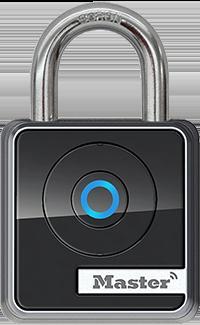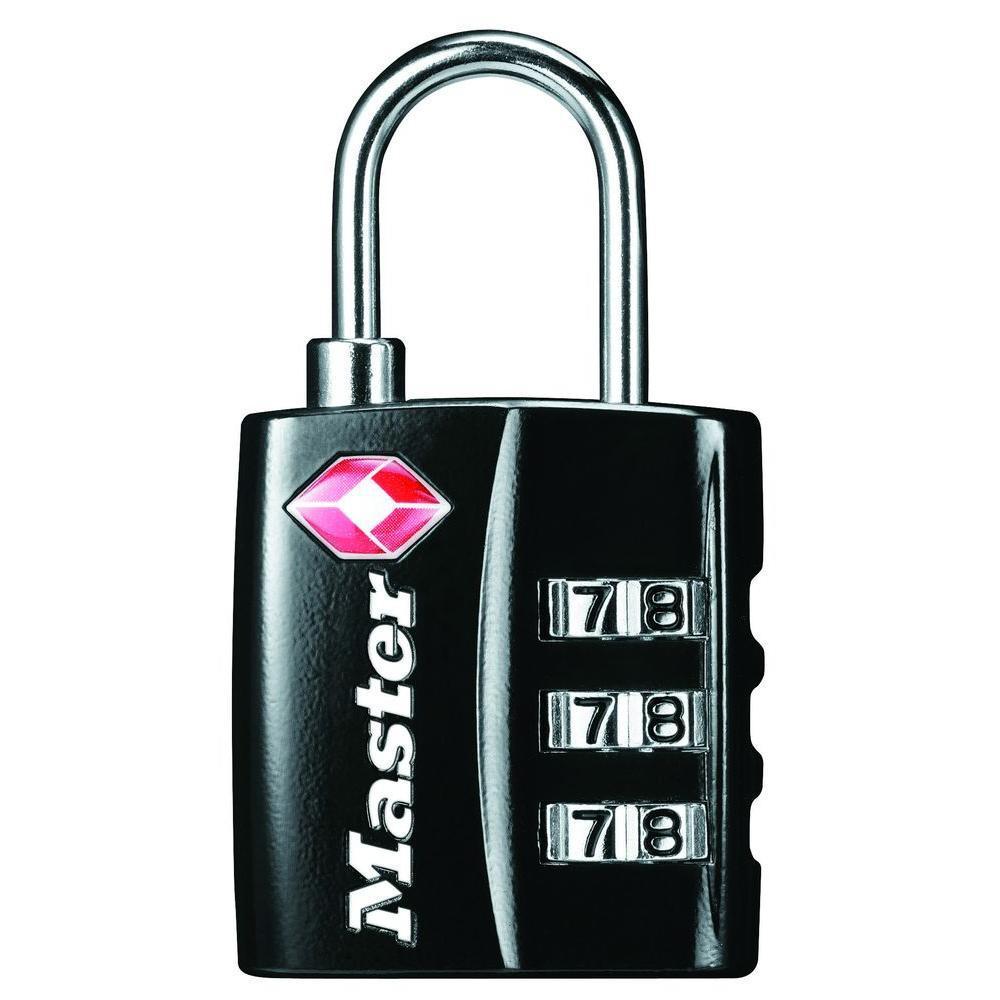The first image is the image on the left, the second image is the image on the right. Considering the images on both sides, is "An image shows a lock with three rows of numbers to enter the combination." valid? Answer yes or no. Yes. The first image is the image on the left, the second image is the image on the right. Given the left and right images, does the statement "At least one image is a manual mechanical combination lock with a logo design other than a blue circle." hold true? Answer yes or no. Yes. The first image is the image on the left, the second image is the image on the right. Analyze the images presented: Is the assertion "One lock features a red diamond shape on the front of a lock near three vertical combination wheels." valid? Answer yes or no. Yes. The first image is the image on the left, the second image is the image on the right. Given the left and right images, does the statement "There is a numbered padlock in one of the images." hold true? Answer yes or no. Yes. 